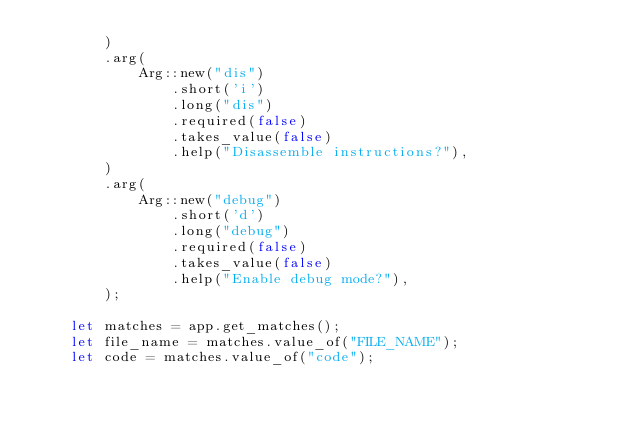<code> <loc_0><loc_0><loc_500><loc_500><_Rust_>        )
        .arg(
            Arg::new("dis")
                .short('i')
                .long("dis")
                .required(false)
                .takes_value(false)
                .help("Disassemble instructions?"),
        )
        .arg(
            Arg::new("debug")
                .short('d')
                .long("debug")
                .required(false)
                .takes_value(false)
                .help("Enable debug mode?"),
        );

    let matches = app.get_matches();
    let file_name = matches.value_of("FILE_NAME");
    let code = matches.value_of("code");</code> 